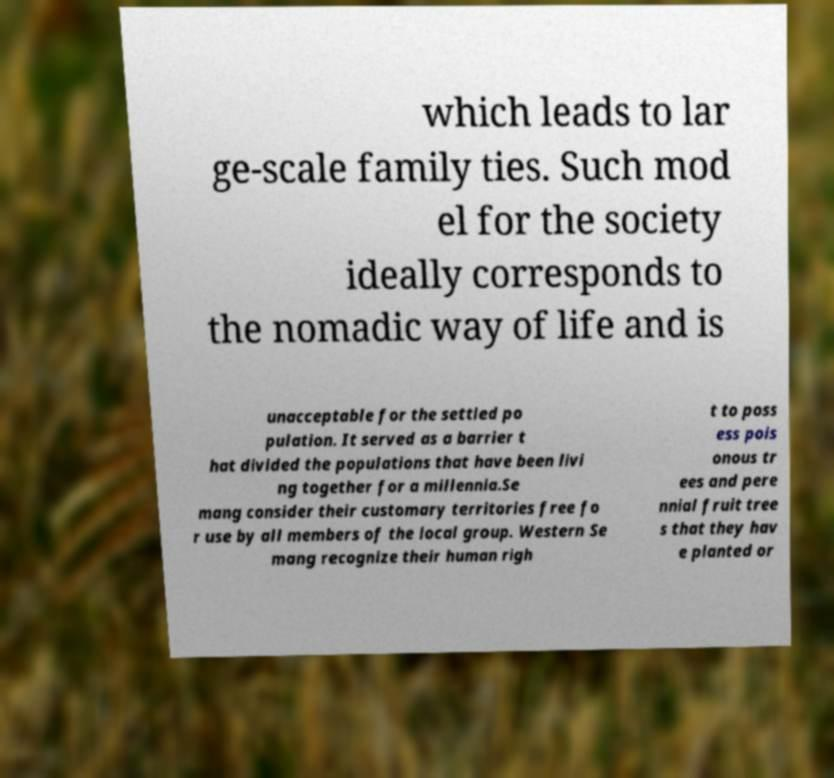What messages or text are displayed in this image? I need them in a readable, typed format. which leads to lar ge-scale family ties. Such mod el for the society ideally corresponds to the nomadic way of life and is unacceptable for the settled po pulation. It served as a barrier t hat divided the populations that have been livi ng together for a millennia.Se mang consider their customary territories free fo r use by all members of the local group. Western Se mang recognize their human righ t to poss ess pois onous tr ees and pere nnial fruit tree s that they hav e planted or 